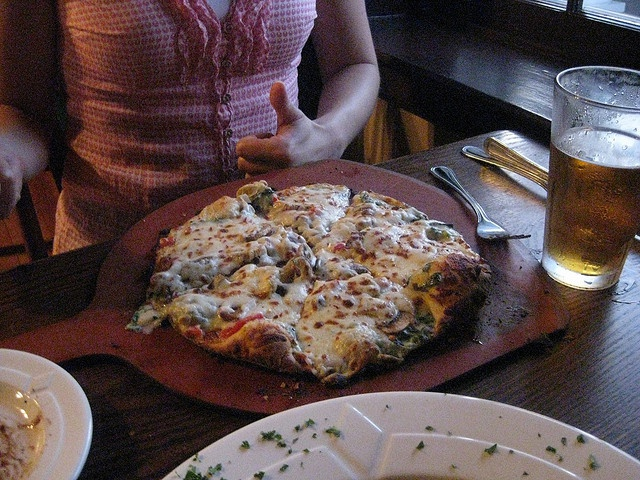Describe the objects in this image and their specific colors. I can see dining table in maroon, black, darkgray, and gray tones, people in maroon, black, and purple tones, pizza in maroon, darkgray, gray, and tan tones, cup in maroon, black, gray, and lavender tones, and spoon in maroon, black, and gray tones in this image. 